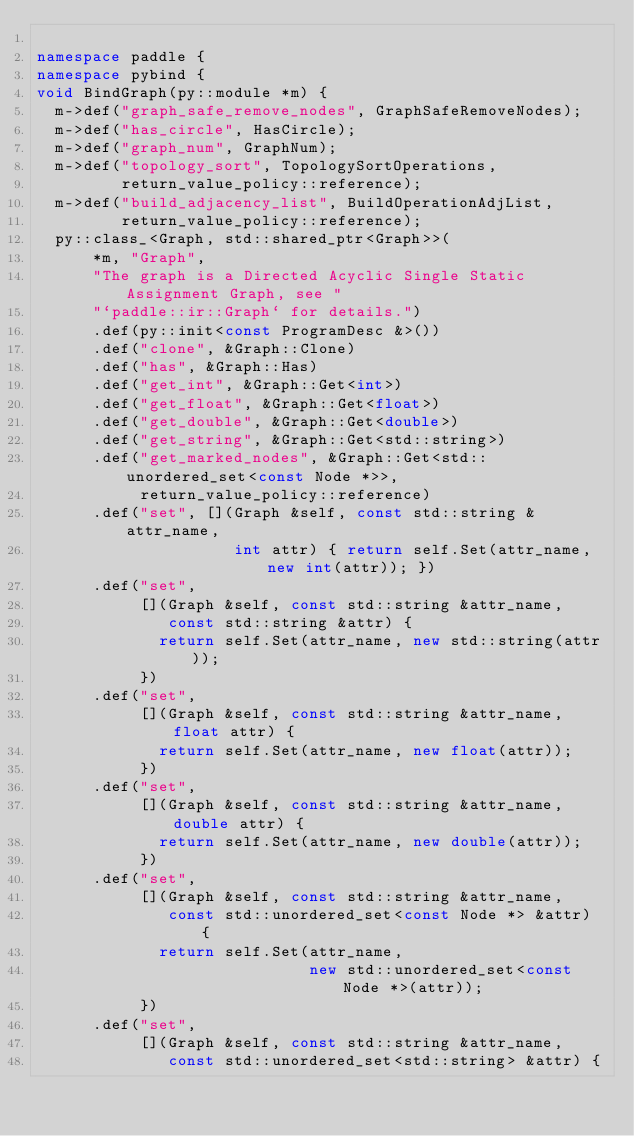Convert code to text. <code><loc_0><loc_0><loc_500><loc_500><_C++_>
namespace paddle {
namespace pybind {
void BindGraph(py::module *m) {
  m->def("graph_safe_remove_nodes", GraphSafeRemoveNodes);
  m->def("has_circle", HasCircle);
  m->def("graph_num", GraphNum);
  m->def("topology_sort", TopologySortOperations,
         return_value_policy::reference);
  m->def("build_adjacency_list", BuildOperationAdjList,
         return_value_policy::reference);
  py::class_<Graph, std::shared_ptr<Graph>>(
      *m, "Graph",
      "The graph is a Directed Acyclic Single Static Assignment Graph, see "
      "`paddle::ir::Graph` for details.")
      .def(py::init<const ProgramDesc &>())
      .def("clone", &Graph::Clone)
      .def("has", &Graph::Has)
      .def("get_int", &Graph::Get<int>)
      .def("get_float", &Graph::Get<float>)
      .def("get_double", &Graph::Get<double>)
      .def("get_string", &Graph::Get<std::string>)
      .def("get_marked_nodes", &Graph::Get<std::unordered_set<const Node *>>,
           return_value_policy::reference)
      .def("set", [](Graph &self, const std::string &attr_name,
                     int attr) { return self.Set(attr_name, new int(attr)); })
      .def("set",
           [](Graph &self, const std::string &attr_name,
              const std::string &attr) {
             return self.Set(attr_name, new std::string(attr));
           })
      .def("set",
           [](Graph &self, const std::string &attr_name, float attr) {
             return self.Set(attr_name, new float(attr));
           })
      .def("set",
           [](Graph &self, const std::string &attr_name, double attr) {
             return self.Set(attr_name, new double(attr));
           })
      .def("set",
           [](Graph &self, const std::string &attr_name,
              const std::unordered_set<const Node *> &attr) {
             return self.Set(attr_name,
                             new std::unordered_set<const Node *>(attr));
           })
      .def("set",
           [](Graph &self, const std::string &attr_name,
              const std::unordered_set<std::string> &attr) {</code> 